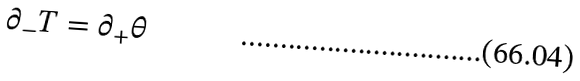<formula> <loc_0><loc_0><loc_500><loc_500>\partial _ { - } T = \partial _ { + } \theta</formula> 